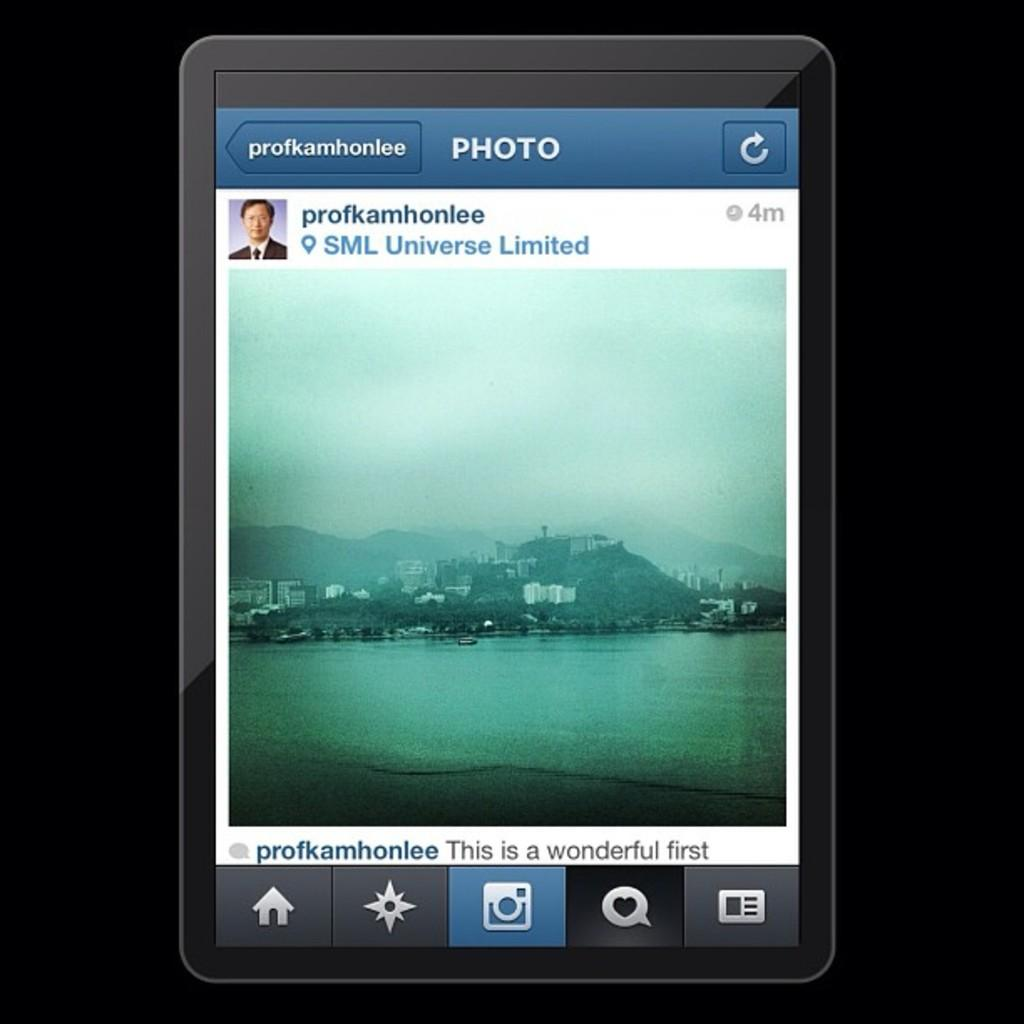<image>
Summarize the visual content of the image. A digital screen showing the profile for user profkamhonlee 